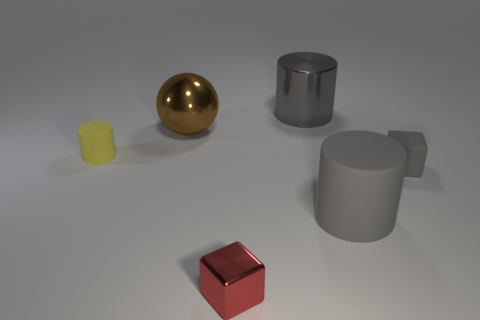There is a metal cylinder; does it have the same color as the large cylinder that is in front of the small gray matte object?
Offer a terse response. Yes. The tiny thing that is the same color as the big metal cylinder is what shape?
Keep it short and to the point. Cube. Are there any big objects that have the same color as the metal cylinder?
Your answer should be very brief. Yes. Is the small matte block the same color as the big shiny cylinder?
Offer a very short reply. Yes. Is there anything else that has the same shape as the big rubber thing?
Offer a terse response. Yes. Are there fewer tiny purple things than tiny yellow matte cylinders?
Ensure brevity in your answer.  Yes. There is a gray thing that is on the left side of the small gray rubber block and in front of the small yellow rubber cylinder; what material is it?
Provide a short and direct response. Rubber. There is a metal thing in front of the gray cube; are there any big objects that are on the right side of it?
Your answer should be compact. Yes. How many things are gray metal objects or yellow matte objects?
Your answer should be compact. 2. The small thing that is to the left of the big gray shiny thing and on the right side of the ball has what shape?
Provide a short and direct response. Cube. 